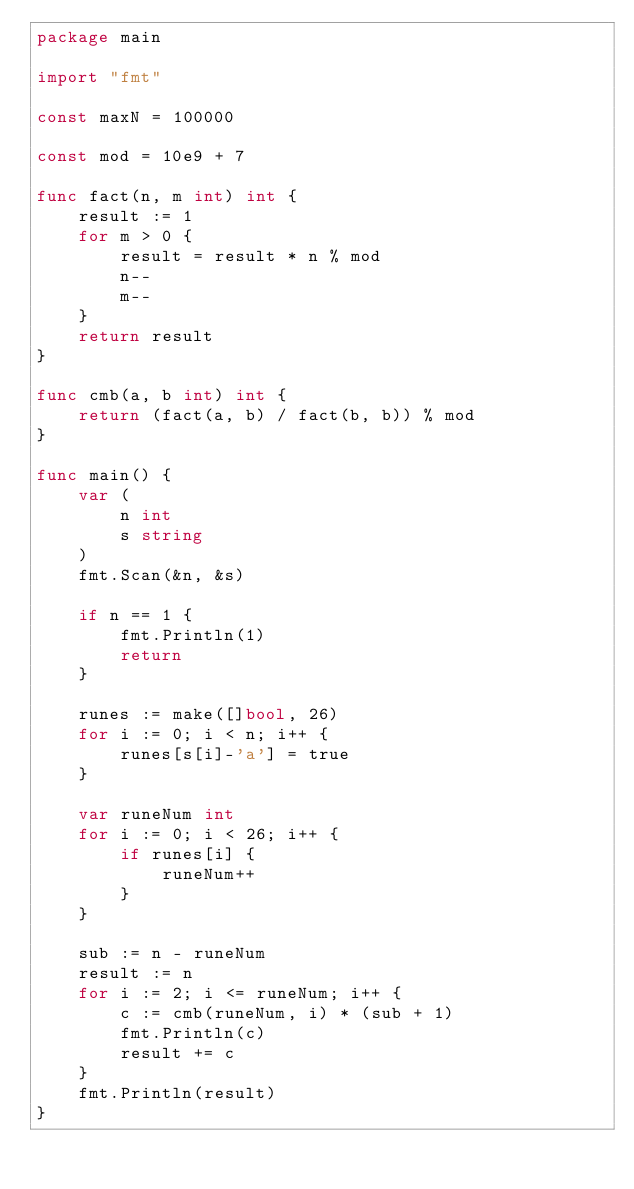<code> <loc_0><loc_0><loc_500><loc_500><_Go_>package main

import "fmt"

const maxN = 100000

const mod = 10e9 + 7

func fact(n, m int) int {
	result := 1
	for m > 0 {
		result = result * n % mod
		n--
		m--
	}
	return result
}

func cmb(a, b int) int {
	return (fact(a, b) / fact(b, b)) % mod
}

func main() {
	var (
		n int
		s string
	)
	fmt.Scan(&n, &s)

	if n == 1 {
		fmt.Println(1)
		return
	}

	runes := make([]bool, 26)
	for i := 0; i < n; i++ {
		runes[s[i]-'a'] = true
	}

	var runeNum int
	for i := 0; i < 26; i++ {
		if runes[i] {
			runeNum++
		}
	}

	sub := n - runeNum
	result := n
	for i := 2; i <= runeNum; i++ {
		c := cmb(runeNum, i) * (sub + 1)
		fmt.Println(c)
		result += c
	}
	fmt.Println(result)
}</code> 